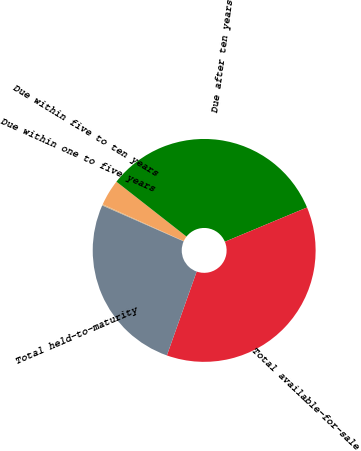Convert chart to OTSL. <chart><loc_0><loc_0><loc_500><loc_500><pie_chart><fcel>Due within one to five years<fcel>Due within five to ten years<fcel>Due after ten years<fcel>Total available-for-sale<fcel>Total held-to-maturity<nl><fcel>0.18%<fcel>3.79%<fcel>33.13%<fcel>36.73%<fcel>26.17%<nl></chart> 